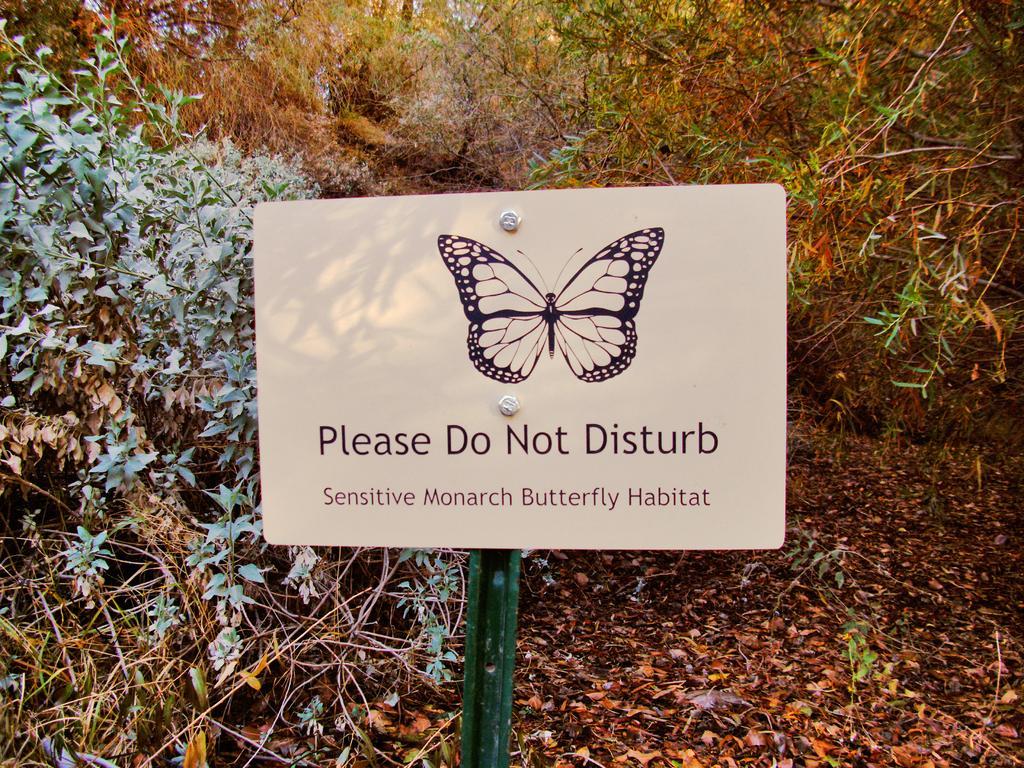Can you describe this image briefly? This is the board, which is attached to the pole. These are the trees and plants. I can see the dried leaves lying on the ground. 